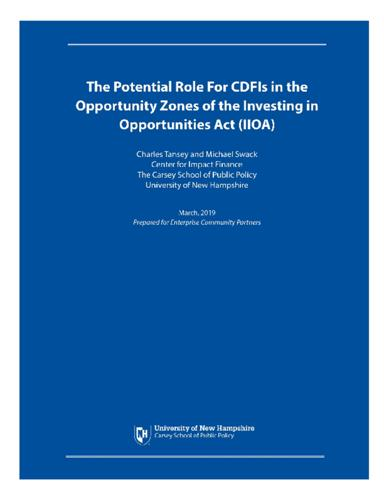What are the possible impacts of the document's recommendations on communities? The document's recommendations could significantly influence community development by providing guidance on how CDFIs could leverage investments in Opportunity Zones, potentially sparking economic revitalization and improved social outcomes in underinvested areas. 